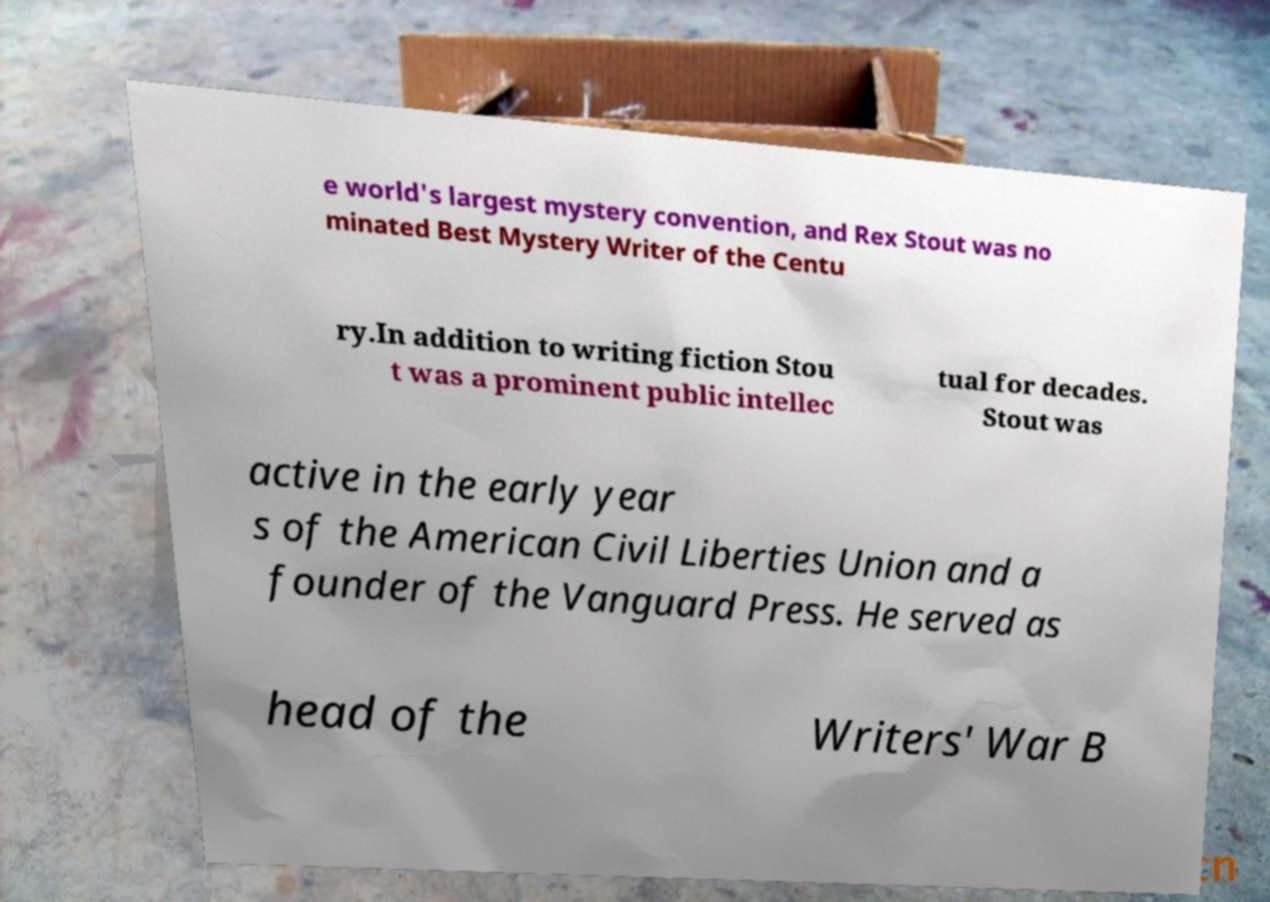There's text embedded in this image that I need extracted. Can you transcribe it verbatim? e world's largest mystery convention, and Rex Stout was no minated Best Mystery Writer of the Centu ry.In addition to writing fiction Stou t was a prominent public intellec tual for decades. Stout was active in the early year s of the American Civil Liberties Union and a founder of the Vanguard Press. He served as head of the Writers' War B 